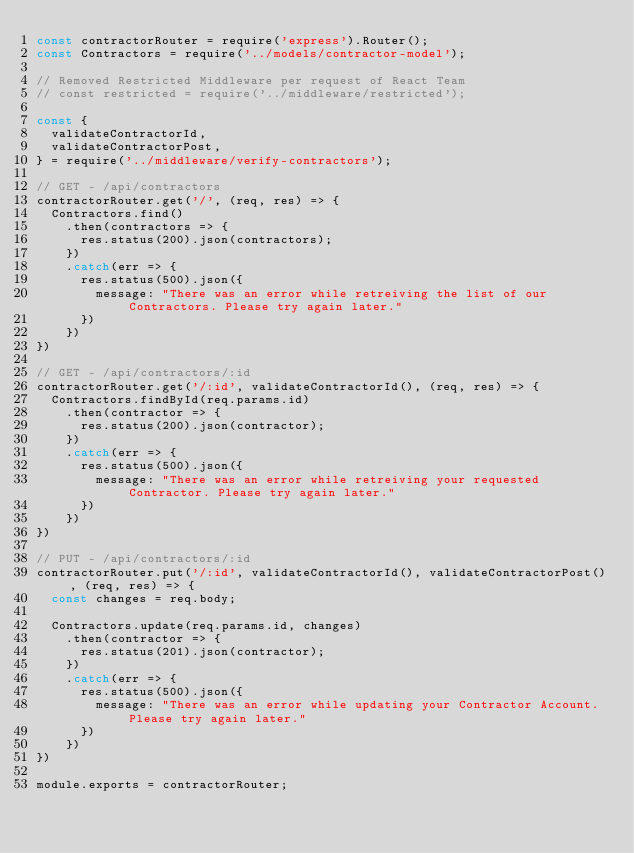<code> <loc_0><loc_0><loc_500><loc_500><_JavaScript_>const contractorRouter = require('express').Router();
const Contractors = require('../models/contractor-model');

// Removed Restricted Middleware per request of React Team
// const restricted = require('../middleware/restricted');

const {
  validateContractorId,
  validateContractorPost,
} = require('../middleware/verify-contractors');

// GET - /api/contractors
contractorRouter.get('/', (req, res) => {
  Contractors.find()
    .then(contractors => {
      res.status(200).json(contractors);
    })
    .catch(err => {
      res.status(500).json({
        message: "There was an error while retreiving the list of our Contractors. Please try again later."
      })
    })
})

// GET - /api/contractors/:id
contractorRouter.get('/:id', validateContractorId(), (req, res) => {
  Contractors.findById(req.params.id)
    .then(contractor => {
      res.status(200).json(contractor);
    })
    .catch(err => {
      res.status(500).json({
        message: "There was an error while retreiving your requested Contractor. Please try again later."
      })
    })
})

// PUT - /api/contractors/:id
contractorRouter.put('/:id', validateContractorId(), validateContractorPost(), (req, res) => {
  const changes = req.body;

  Contractors.update(req.params.id, changes)
    .then(contractor => {
      res.status(201).json(contractor);
    })
    .catch(err => {
      res.status(500).json({
        message: "There was an error while updating your Contractor Account. Please try again later."
      })
    })
})

module.exports = contractorRouter;</code> 